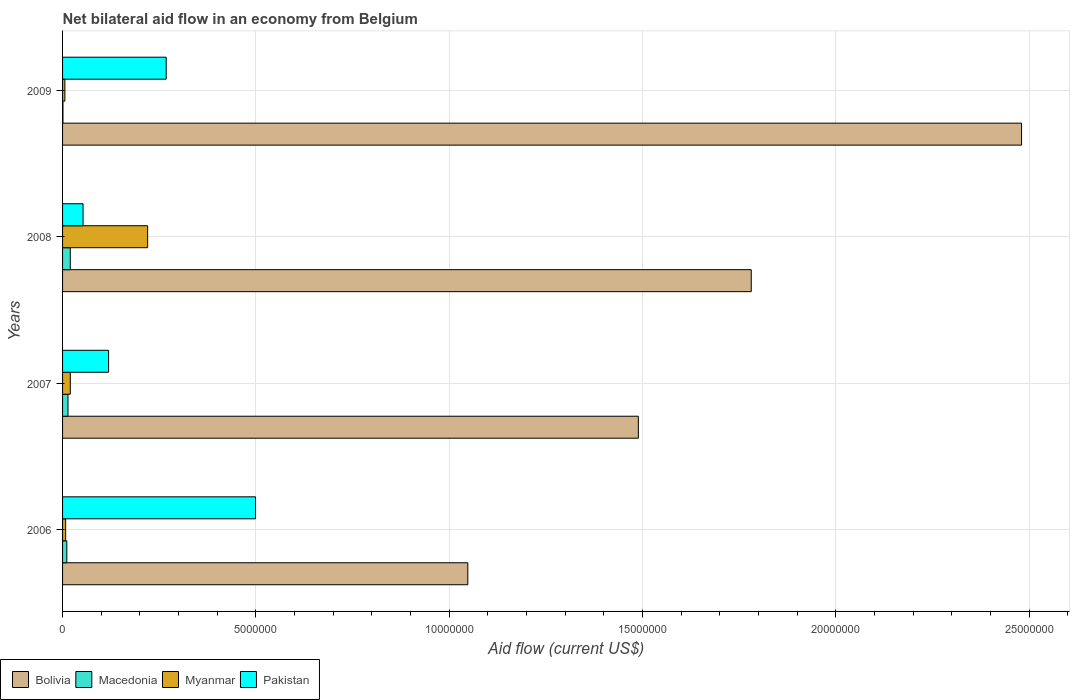How many different coloured bars are there?
Your answer should be compact. 4. Are the number of bars per tick equal to the number of legend labels?
Offer a terse response. Yes. Across all years, what is the maximum net bilateral aid flow in Myanmar?
Provide a succinct answer. 2.20e+06. In which year was the net bilateral aid flow in Pakistan minimum?
Your answer should be very brief. 2008. What is the total net bilateral aid flow in Pakistan in the graph?
Keep it short and to the point. 9.39e+06. What is the difference between the net bilateral aid flow in Myanmar in 2006 and that in 2008?
Your response must be concise. -2.12e+06. What is the average net bilateral aid flow in Myanmar per year?
Offer a very short reply. 6.35e+05. In the year 2007, what is the difference between the net bilateral aid flow in Myanmar and net bilateral aid flow in Bolivia?
Make the answer very short. -1.47e+07. In how many years, is the net bilateral aid flow in Myanmar greater than 22000000 US$?
Make the answer very short. 0. What is the ratio of the net bilateral aid flow in Macedonia in 2007 to that in 2008?
Ensure brevity in your answer.  0.7. What is the difference between the highest and the second highest net bilateral aid flow in Myanmar?
Provide a short and direct response. 2.00e+06. What is the difference between the highest and the lowest net bilateral aid flow in Myanmar?
Make the answer very short. 2.14e+06. In how many years, is the net bilateral aid flow in Macedonia greater than the average net bilateral aid flow in Macedonia taken over all years?
Your answer should be compact. 2. Is the sum of the net bilateral aid flow in Bolivia in 2006 and 2009 greater than the maximum net bilateral aid flow in Myanmar across all years?
Your answer should be very brief. Yes. Is it the case that in every year, the sum of the net bilateral aid flow in Myanmar and net bilateral aid flow in Pakistan is greater than the sum of net bilateral aid flow in Macedonia and net bilateral aid flow in Bolivia?
Make the answer very short. No. What does the 2nd bar from the top in 2009 represents?
Offer a very short reply. Myanmar. What does the 2nd bar from the bottom in 2008 represents?
Make the answer very short. Macedonia. How many bars are there?
Offer a terse response. 16. Are all the bars in the graph horizontal?
Your answer should be compact. Yes. Does the graph contain any zero values?
Make the answer very short. No. How many legend labels are there?
Make the answer very short. 4. How are the legend labels stacked?
Your response must be concise. Horizontal. What is the title of the graph?
Your answer should be very brief. Net bilateral aid flow in an economy from Belgium. What is the label or title of the X-axis?
Your answer should be very brief. Aid flow (current US$). What is the Aid flow (current US$) in Bolivia in 2006?
Offer a very short reply. 1.05e+07. What is the Aid flow (current US$) in Myanmar in 2006?
Ensure brevity in your answer.  8.00e+04. What is the Aid flow (current US$) of Pakistan in 2006?
Offer a very short reply. 4.99e+06. What is the Aid flow (current US$) of Bolivia in 2007?
Provide a succinct answer. 1.49e+07. What is the Aid flow (current US$) of Macedonia in 2007?
Your answer should be compact. 1.40e+05. What is the Aid flow (current US$) in Myanmar in 2007?
Keep it short and to the point. 2.00e+05. What is the Aid flow (current US$) in Pakistan in 2007?
Ensure brevity in your answer.  1.19e+06. What is the Aid flow (current US$) in Bolivia in 2008?
Provide a succinct answer. 1.78e+07. What is the Aid flow (current US$) of Myanmar in 2008?
Keep it short and to the point. 2.20e+06. What is the Aid flow (current US$) in Pakistan in 2008?
Your response must be concise. 5.30e+05. What is the Aid flow (current US$) in Bolivia in 2009?
Ensure brevity in your answer.  2.48e+07. What is the Aid flow (current US$) of Pakistan in 2009?
Offer a terse response. 2.68e+06. Across all years, what is the maximum Aid flow (current US$) of Bolivia?
Your answer should be very brief. 2.48e+07. Across all years, what is the maximum Aid flow (current US$) of Macedonia?
Your answer should be very brief. 2.00e+05. Across all years, what is the maximum Aid flow (current US$) of Myanmar?
Make the answer very short. 2.20e+06. Across all years, what is the maximum Aid flow (current US$) of Pakistan?
Keep it short and to the point. 4.99e+06. Across all years, what is the minimum Aid flow (current US$) of Bolivia?
Provide a short and direct response. 1.05e+07. Across all years, what is the minimum Aid flow (current US$) of Myanmar?
Provide a short and direct response. 6.00e+04. Across all years, what is the minimum Aid flow (current US$) in Pakistan?
Provide a short and direct response. 5.30e+05. What is the total Aid flow (current US$) of Bolivia in the graph?
Give a very brief answer. 6.80e+07. What is the total Aid flow (current US$) in Macedonia in the graph?
Ensure brevity in your answer.  4.60e+05. What is the total Aid flow (current US$) of Myanmar in the graph?
Make the answer very short. 2.54e+06. What is the total Aid flow (current US$) of Pakistan in the graph?
Provide a short and direct response. 9.39e+06. What is the difference between the Aid flow (current US$) in Bolivia in 2006 and that in 2007?
Keep it short and to the point. -4.41e+06. What is the difference between the Aid flow (current US$) in Pakistan in 2006 and that in 2007?
Offer a terse response. 3.80e+06. What is the difference between the Aid flow (current US$) in Bolivia in 2006 and that in 2008?
Your response must be concise. -7.33e+06. What is the difference between the Aid flow (current US$) of Macedonia in 2006 and that in 2008?
Keep it short and to the point. -9.00e+04. What is the difference between the Aid flow (current US$) in Myanmar in 2006 and that in 2008?
Offer a terse response. -2.12e+06. What is the difference between the Aid flow (current US$) in Pakistan in 2006 and that in 2008?
Give a very brief answer. 4.46e+06. What is the difference between the Aid flow (current US$) of Bolivia in 2006 and that in 2009?
Keep it short and to the point. -1.43e+07. What is the difference between the Aid flow (current US$) in Macedonia in 2006 and that in 2009?
Offer a terse response. 1.00e+05. What is the difference between the Aid flow (current US$) of Myanmar in 2006 and that in 2009?
Ensure brevity in your answer.  2.00e+04. What is the difference between the Aid flow (current US$) in Pakistan in 2006 and that in 2009?
Your answer should be very brief. 2.31e+06. What is the difference between the Aid flow (current US$) of Bolivia in 2007 and that in 2008?
Make the answer very short. -2.92e+06. What is the difference between the Aid flow (current US$) in Macedonia in 2007 and that in 2008?
Offer a terse response. -6.00e+04. What is the difference between the Aid flow (current US$) of Pakistan in 2007 and that in 2008?
Provide a succinct answer. 6.60e+05. What is the difference between the Aid flow (current US$) of Bolivia in 2007 and that in 2009?
Your answer should be compact. -9.91e+06. What is the difference between the Aid flow (current US$) in Myanmar in 2007 and that in 2009?
Make the answer very short. 1.40e+05. What is the difference between the Aid flow (current US$) of Pakistan in 2007 and that in 2009?
Provide a succinct answer. -1.49e+06. What is the difference between the Aid flow (current US$) in Bolivia in 2008 and that in 2009?
Provide a succinct answer. -6.99e+06. What is the difference between the Aid flow (current US$) in Macedonia in 2008 and that in 2009?
Ensure brevity in your answer.  1.90e+05. What is the difference between the Aid flow (current US$) of Myanmar in 2008 and that in 2009?
Your response must be concise. 2.14e+06. What is the difference between the Aid flow (current US$) in Pakistan in 2008 and that in 2009?
Offer a very short reply. -2.15e+06. What is the difference between the Aid flow (current US$) in Bolivia in 2006 and the Aid flow (current US$) in Macedonia in 2007?
Provide a succinct answer. 1.03e+07. What is the difference between the Aid flow (current US$) of Bolivia in 2006 and the Aid flow (current US$) of Myanmar in 2007?
Your answer should be compact. 1.03e+07. What is the difference between the Aid flow (current US$) in Bolivia in 2006 and the Aid flow (current US$) in Pakistan in 2007?
Your answer should be compact. 9.29e+06. What is the difference between the Aid flow (current US$) of Macedonia in 2006 and the Aid flow (current US$) of Pakistan in 2007?
Offer a very short reply. -1.08e+06. What is the difference between the Aid flow (current US$) in Myanmar in 2006 and the Aid flow (current US$) in Pakistan in 2007?
Ensure brevity in your answer.  -1.11e+06. What is the difference between the Aid flow (current US$) in Bolivia in 2006 and the Aid flow (current US$) in Macedonia in 2008?
Keep it short and to the point. 1.03e+07. What is the difference between the Aid flow (current US$) in Bolivia in 2006 and the Aid flow (current US$) in Myanmar in 2008?
Keep it short and to the point. 8.28e+06. What is the difference between the Aid flow (current US$) in Bolivia in 2006 and the Aid flow (current US$) in Pakistan in 2008?
Provide a succinct answer. 9.95e+06. What is the difference between the Aid flow (current US$) of Macedonia in 2006 and the Aid flow (current US$) of Myanmar in 2008?
Give a very brief answer. -2.09e+06. What is the difference between the Aid flow (current US$) of Macedonia in 2006 and the Aid flow (current US$) of Pakistan in 2008?
Ensure brevity in your answer.  -4.20e+05. What is the difference between the Aid flow (current US$) in Myanmar in 2006 and the Aid flow (current US$) in Pakistan in 2008?
Ensure brevity in your answer.  -4.50e+05. What is the difference between the Aid flow (current US$) of Bolivia in 2006 and the Aid flow (current US$) of Macedonia in 2009?
Offer a terse response. 1.05e+07. What is the difference between the Aid flow (current US$) in Bolivia in 2006 and the Aid flow (current US$) in Myanmar in 2009?
Offer a very short reply. 1.04e+07. What is the difference between the Aid flow (current US$) in Bolivia in 2006 and the Aid flow (current US$) in Pakistan in 2009?
Offer a terse response. 7.80e+06. What is the difference between the Aid flow (current US$) of Macedonia in 2006 and the Aid flow (current US$) of Pakistan in 2009?
Ensure brevity in your answer.  -2.57e+06. What is the difference between the Aid flow (current US$) in Myanmar in 2006 and the Aid flow (current US$) in Pakistan in 2009?
Your answer should be compact. -2.60e+06. What is the difference between the Aid flow (current US$) in Bolivia in 2007 and the Aid flow (current US$) in Macedonia in 2008?
Provide a short and direct response. 1.47e+07. What is the difference between the Aid flow (current US$) in Bolivia in 2007 and the Aid flow (current US$) in Myanmar in 2008?
Your answer should be very brief. 1.27e+07. What is the difference between the Aid flow (current US$) in Bolivia in 2007 and the Aid flow (current US$) in Pakistan in 2008?
Give a very brief answer. 1.44e+07. What is the difference between the Aid flow (current US$) in Macedonia in 2007 and the Aid flow (current US$) in Myanmar in 2008?
Ensure brevity in your answer.  -2.06e+06. What is the difference between the Aid flow (current US$) of Macedonia in 2007 and the Aid flow (current US$) of Pakistan in 2008?
Make the answer very short. -3.90e+05. What is the difference between the Aid flow (current US$) in Myanmar in 2007 and the Aid flow (current US$) in Pakistan in 2008?
Your answer should be compact. -3.30e+05. What is the difference between the Aid flow (current US$) in Bolivia in 2007 and the Aid flow (current US$) in Macedonia in 2009?
Offer a very short reply. 1.49e+07. What is the difference between the Aid flow (current US$) in Bolivia in 2007 and the Aid flow (current US$) in Myanmar in 2009?
Provide a succinct answer. 1.48e+07. What is the difference between the Aid flow (current US$) in Bolivia in 2007 and the Aid flow (current US$) in Pakistan in 2009?
Provide a succinct answer. 1.22e+07. What is the difference between the Aid flow (current US$) in Macedonia in 2007 and the Aid flow (current US$) in Myanmar in 2009?
Your response must be concise. 8.00e+04. What is the difference between the Aid flow (current US$) of Macedonia in 2007 and the Aid flow (current US$) of Pakistan in 2009?
Provide a succinct answer. -2.54e+06. What is the difference between the Aid flow (current US$) in Myanmar in 2007 and the Aid flow (current US$) in Pakistan in 2009?
Offer a terse response. -2.48e+06. What is the difference between the Aid flow (current US$) of Bolivia in 2008 and the Aid flow (current US$) of Macedonia in 2009?
Ensure brevity in your answer.  1.78e+07. What is the difference between the Aid flow (current US$) in Bolivia in 2008 and the Aid flow (current US$) in Myanmar in 2009?
Keep it short and to the point. 1.78e+07. What is the difference between the Aid flow (current US$) in Bolivia in 2008 and the Aid flow (current US$) in Pakistan in 2009?
Keep it short and to the point. 1.51e+07. What is the difference between the Aid flow (current US$) of Macedonia in 2008 and the Aid flow (current US$) of Pakistan in 2009?
Give a very brief answer. -2.48e+06. What is the difference between the Aid flow (current US$) in Myanmar in 2008 and the Aid flow (current US$) in Pakistan in 2009?
Your answer should be very brief. -4.80e+05. What is the average Aid flow (current US$) of Bolivia per year?
Offer a very short reply. 1.70e+07. What is the average Aid flow (current US$) of Macedonia per year?
Your response must be concise. 1.15e+05. What is the average Aid flow (current US$) of Myanmar per year?
Offer a terse response. 6.35e+05. What is the average Aid flow (current US$) in Pakistan per year?
Ensure brevity in your answer.  2.35e+06. In the year 2006, what is the difference between the Aid flow (current US$) in Bolivia and Aid flow (current US$) in Macedonia?
Your answer should be compact. 1.04e+07. In the year 2006, what is the difference between the Aid flow (current US$) of Bolivia and Aid flow (current US$) of Myanmar?
Offer a terse response. 1.04e+07. In the year 2006, what is the difference between the Aid flow (current US$) of Bolivia and Aid flow (current US$) of Pakistan?
Keep it short and to the point. 5.49e+06. In the year 2006, what is the difference between the Aid flow (current US$) of Macedonia and Aid flow (current US$) of Myanmar?
Offer a terse response. 3.00e+04. In the year 2006, what is the difference between the Aid flow (current US$) in Macedonia and Aid flow (current US$) in Pakistan?
Make the answer very short. -4.88e+06. In the year 2006, what is the difference between the Aid flow (current US$) of Myanmar and Aid flow (current US$) of Pakistan?
Keep it short and to the point. -4.91e+06. In the year 2007, what is the difference between the Aid flow (current US$) in Bolivia and Aid flow (current US$) in Macedonia?
Provide a succinct answer. 1.48e+07. In the year 2007, what is the difference between the Aid flow (current US$) of Bolivia and Aid flow (current US$) of Myanmar?
Your answer should be compact. 1.47e+07. In the year 2007, what is the difference between the Aid flow (current US$) in Bolivia and Aid flow (current US$) in Pakistan?
Ensure brevity in your answer.  1.37e+07. In the year 2007, what is the difference between the Aid flow (current US$) of Macedonia and Aid flow (current US$) of Myanmar?
Provide a short and direct response. -6.00e+04. In the year 2007, what is the difference between the Aid flow (current US$) of Macedonia and Aid flow (current US$) of Pakistan?
Your answer should be compact. -1.05e+06. In the year 2007, what is the difference between the Aid flow (current US$) of Myanmar and Aid flow (current US$) of Pakistan?
Provide a succinct answer. -9.90e+05. In the year 2008, what is the difference between the Aid flow (current US$) of Bolivia and Aid flow (current US$) of Macedonia?
Make the answer very short. 1.76e+07. In the year 2008, what is the difference between the Aid flow (current US$) in Bolivia and Aid flow (current US$) in Myanmar?
Your response must be concise. 1.56e+07. In the year 2008, what is the difference between the Aid flow (current US$) of Bolivia and Aid flow (current US$) of Pakistan?
Keep it short and to the point. 1.73e+07. In the year 2008, what is the difference between the Aid flow (current US$) of Macedonia and Aid flow (current US$) of Myanmar?
Ensure brevity in your answer.  -2.00e+06. In the year 2008, what is the difference between the Aid flow (current US$) of Macedonia and Aid flow (current US$) of Pakistan?
Offer a terse response. -3.30e+05. In the year 2008, what is the difference between the Aid flow (current US$) of Myanmar and Aid flow (current US$) of Pakistan?
Keep it short and to the point. 1.67e+06. In the year 2009, what is the difference between the Aid flow (current US$) in Bolivia and Aid flow (current US$) in Macedonia?
Provide a succinct answer. 2.48e+07. In the year 2009, what is the difference between the Aid flow (current US$) of Bolivia and Aid flow (current US$) of Myanmar?
Offer a very short reply. 2.47e+07. In the year 2009, what is the difference between the Aid flow (current US$) in Bolivia and Aid flow (current US$) in Pakistan?
Provide a short and direct response. 2.21e+07. In the year 2009, what is the difference between the Aid flow (current US$) of Macedonia and Aid flow (current US$) of Myanmar?
Make the answer very short. -5.00e+04. In the year 2009, what is the difference between the Aid flow (current US$) in Macedonia and Aid flow (current US$) in Pakistan?
Your answer should be very brief. -2.67e+06. In the year 2009, what is the difference between the Aid flow (current US$) in Myanmar and Aid flow (current US$) in Pakistan?
Your answer should be compact. -2.62e+06. What is the ratio of the Aid flow (current US$) of Bolivia in 2006 to that in 2007?
Offer a terse response. 0.7. What is the ratio of the Aid flow (current US$) in Macedonia in 2006 to that in 2007?
Keep it short and to the point. 0.79. What is the ratio of the Aid flow (current US$) of Pakistan in 2006 to that in 2007?
Your answer should be very brief. 4.19. What is the ratio of the Aid flow (current US$) in Bolivia in 2006 to that in 2008?
Provide a succinct answer. 0.59. What is the ratio of the Aid flow (current US$) of Macedonia in 2006 to that in 2008?
Provide a short and direct response. 0.55. What is the ratio of the Aid flow (current US$) of Myanmar in 2006 to that in 2008?
Provide a short and direct response. 0.04. What is the ratio of the Aid flow (current US$) of Pakistan in 2006 to that in 2008?
Your answer should be compact. 9.42. What is the ratio of the Aid flow (current US$) of Bolivia in 2006 to that in 2009?
Provide a short and direct response. 0.42. What is the ratio of the Aid flow (current US$) of Myanmar in 2006 to that in 2009?
Offer a very short reply. 1.33. What is the ratio of the Aid flow (current US$) of Pakistan in 2006 to that in 2009?
Offer a very short reply. 1.86. What is the ratio of the Aid flow (current US$) of Bolivia in 2007 to that in 2008?
Offer a terse response. 0.84. What is the ratio of the Aid flow (current US$) in Myanmar in 2007 to that in 2008?
Keep it short and to the point. 0.09. What is the ratio of the Aid flow (current US$) in Pakistan in 2007 to that in 2008?
Ensure brevity in your answer.  2.25. What is the ratio of the Aid flow (current US$) in Bolivia in 2007 to that in 2009?
Your response must be concise. 0.6. What is the ratio of the Aid flow (current US$) in Macedonia in 2007 to that in 2009?
Your response must be concise. 14. What is the ratio of the Aid flow (current US$) of Pakistan in 2007 to that in 2009?
Offer a terse response. 0.44. What is the ratio of the Aid flow (current US$) of Bolivia in 2008 to that in 2009?
Offer a very short reply. 0.72. What is the ratio of the Aid flow (current US$) of Myanmar in 2008 to that in 2009?
Ensure brevity in your answer.  36.67. What is the ratio of the Aid flow (current US$) in Pakistan in 2008 to that in 2009?
Offer a very short reply. 0.2. What is the difference between the highest and the second highest Aid flow (current US$) of Bolivia?
Your answer should be very brief. 6.99e+06. What is the difference between the highest and the second highest Aid flow (current US$) of Pakistan?
Provide a short and direct response. 2.31e+06. What is the difference between the highest and the lowest Aid flow (current US$) of Bolivia?
Your response must be concise. 1.43e+07. What is the difference between the highest and the lowest Aid flow (current US$) of Macedonia?
Your answer should be very brief. 1.90e+05. What is the difference between the highest and the lowest Aid flow (current US$) of Myanmar?
Provide a short and direct response. 2.14e+06. What is the difference between the highest and the lowest Aid flow (current US$) in Pakistan?
Provide a succinct answer. 4.46e+06. 